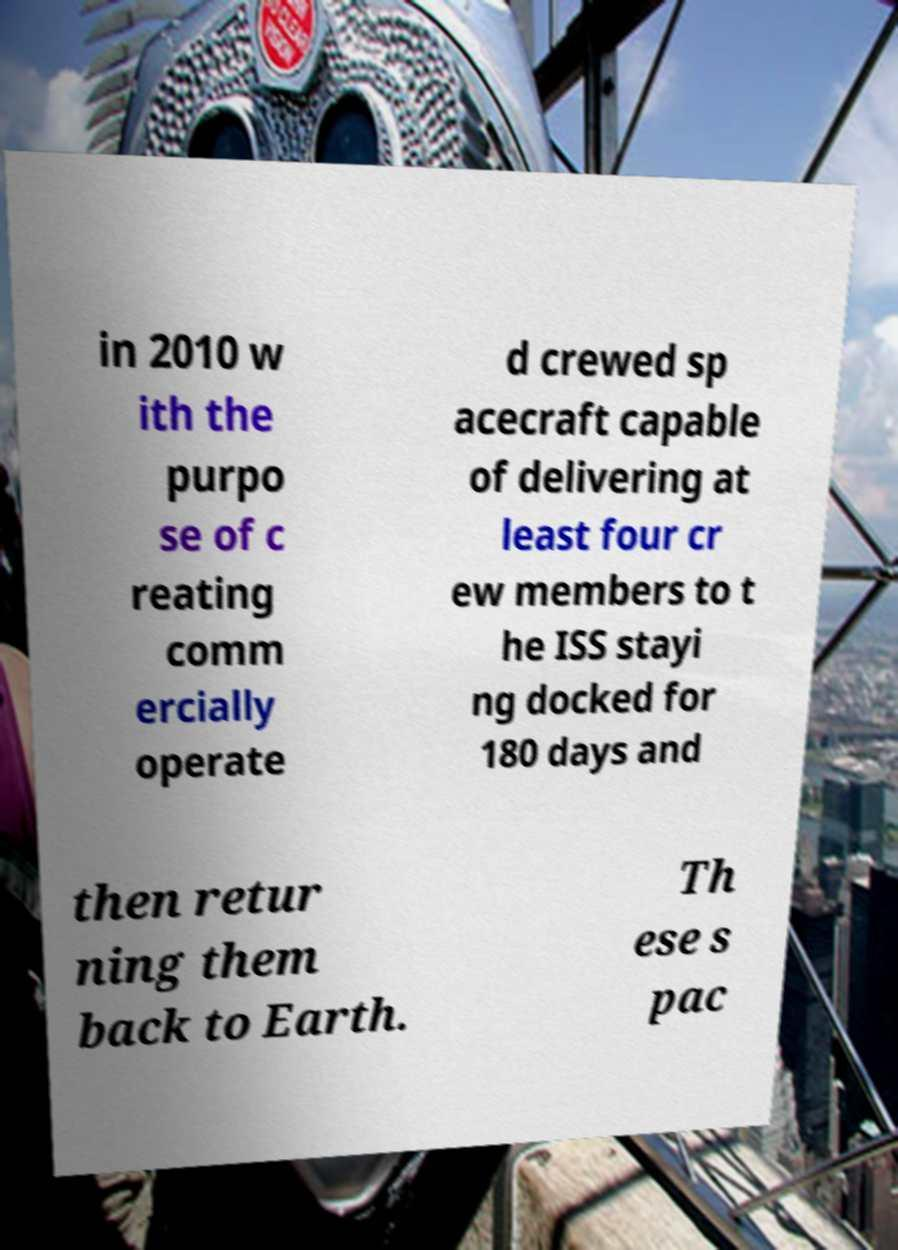Can you accurately transcribe the text from the provided image for me? in 2010 w ith the purpo se of c reating comm ercially operate d crewed sp acecraft capable of delivering at least four cr ew members to t he ISS stayi ng docked for 180 days and then retur ning them back to Earth. Th ese s pac 